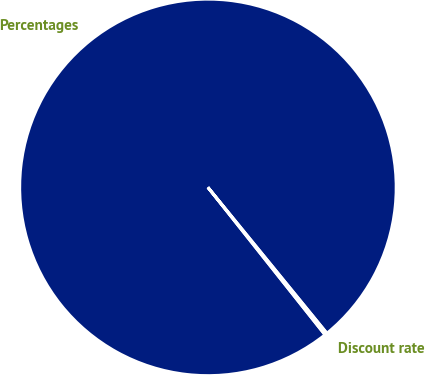Convert chart to OTSL. <chart><loc_0><loc_0><loc_500><loc_500><pie_chart><fcel>Percentages<fcel>Discount rate<nl><fcel>99.79%<fcel>0.21%<nl></chart> 